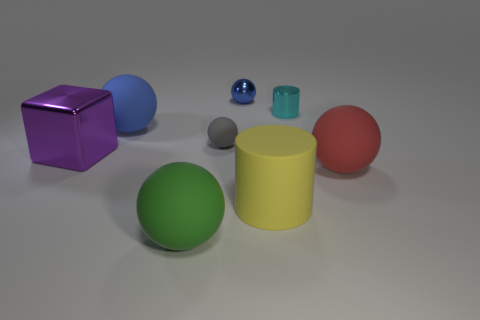What is the color of the small shiny cylinder?
Offer a terse response. Cyan. Is there a tiny cylinder that is in front of the large matte thing that is in front of the rubber cylinder?
Offer a very short reply. No. What number of yellow matte cylinders have the same size as the shiny cylinder?
Make the answer very short. 0. There is a big ball on the right side of the small thing in front of the cyan metal thing; what number of tiny gray things are in front of it?
Make the answer very short. 0. How many metal things are behind the big block and on the left side of the yellow matte thing?
Your response must be concise. 1. Are there any other things that have the same color as the metal cube?
Keep it short and to the point. No. How many matte objects are either large purple things or gray objects?
Make the answer very short. 1. What material is the blue object to the left of the big sphere that is in front of the large sphere right of the tiny blue ball?
Your answer should be very brief. Rubber. There is a blue sphere left of the large thing in front of the large rubber cylinder; what is its material?
Your answer should be very brief. Rubber. There is a cylinder that is in front of the big shiny block; is its size the same as the gray matte thing to the right of the large metallic thing?
Provide a short and direct response. No. 